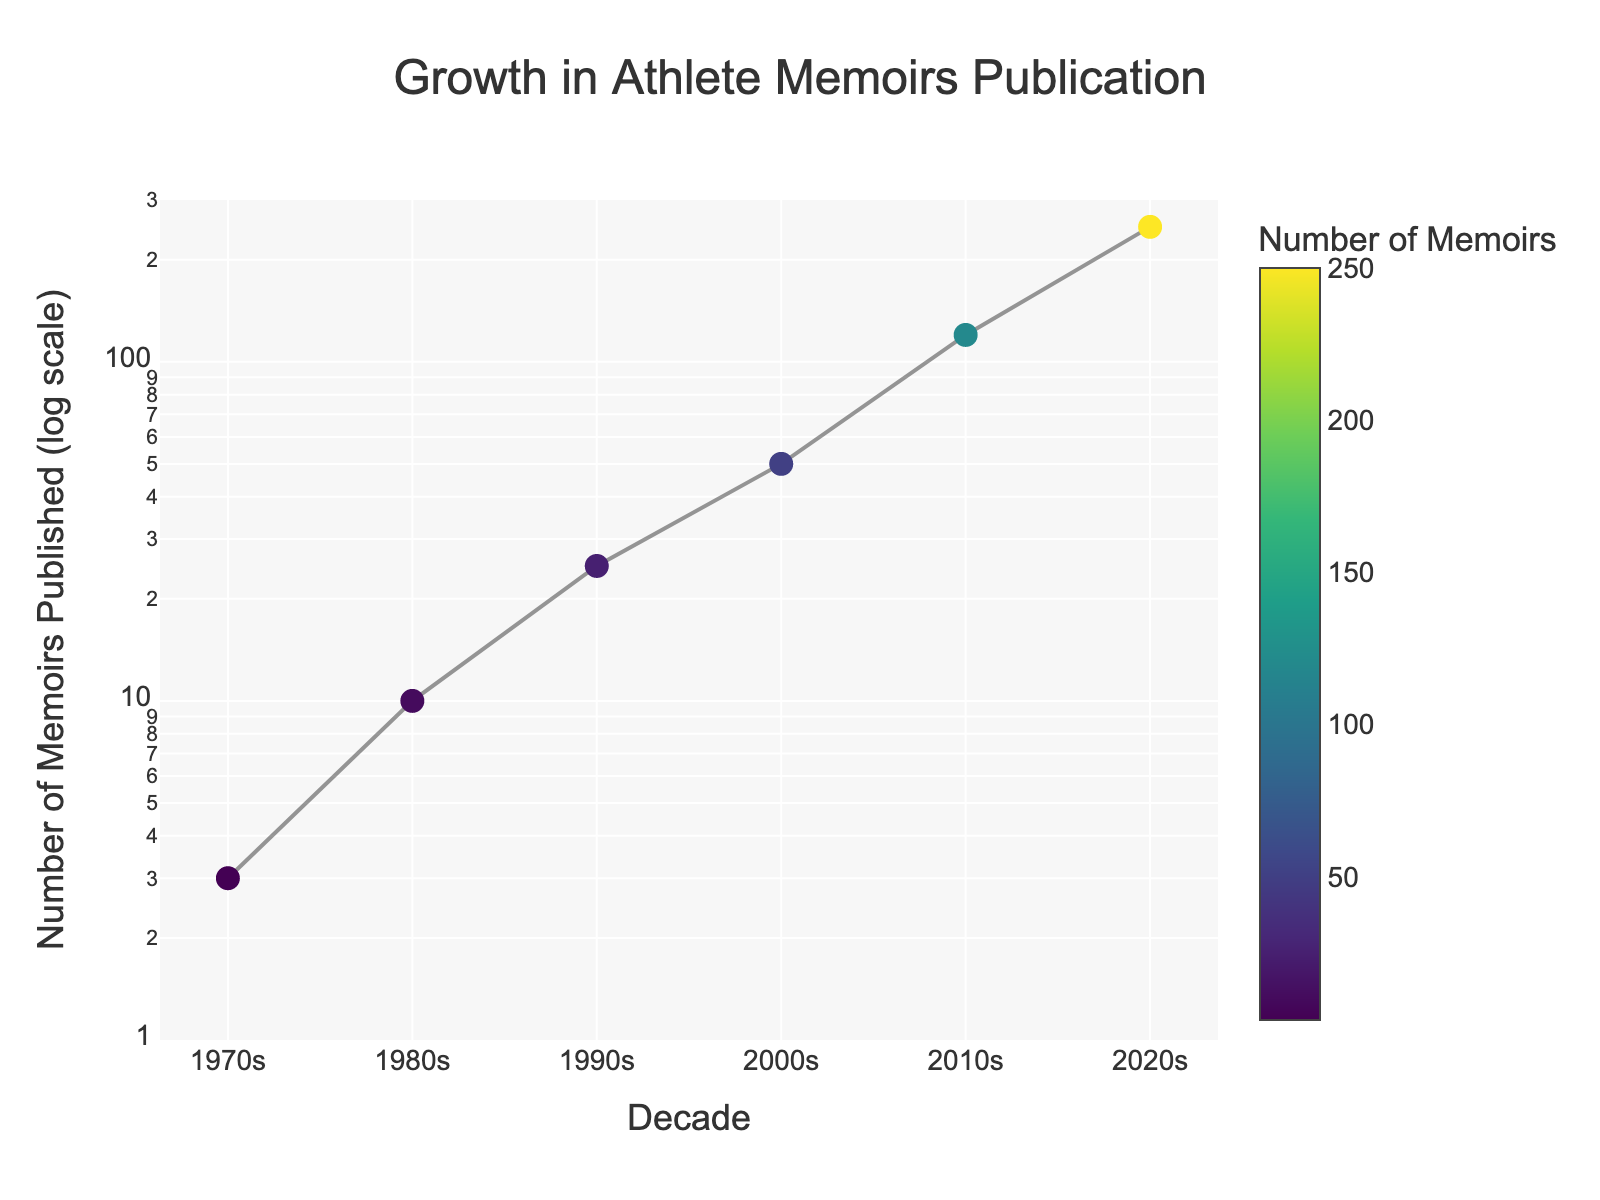What is the title of the figure? The title of the figure is displayed at the top and reads "Growth in Athlete Memoirs Publication."
Answer: Growth in Athlete Memoirs Publication Which decade shows the highest number of athlete memoirs published? By observing the y-axis and the annotations for each decade, it is clear that the 2020s show the highest number of 250 athlete memoirs published.
Answer: 2020s What is the number of athlete memoirs published in the 1980s? The annotation near the data point for the 1980s shows the number of athlete memoirs published, which is 10.
Answer: 10 How many more athlete memoirs were published in the 2000s compared to the 1990s? The number of memoirs published in the 2000s is 50, and in the 1990s, it is 25. The difference is 50 - 25 = 25 memoirs.
Answer: 25 By what factor did the number of published athlete memoirs increase from the 1990s to the 2010s? The number of memoirs published in the 1990s is 25. In the 2010s, it is 120. The factor of increase is 120 ÷ 25 = 4.8.
Answer: 4.8 What logarithmic value range is used for the y-axis? The y-axis is set to a log scale, and the logarithmic range provided in the code is from 0 to log10(300). Log10(300) approximately equals 2.477.
Answer: 0 to 2.477 Which decade shows a doubling of the number of athlete memoirs published compared to the previous decade? Comparing the annotated memoir counts, from the 1970s (3) to the 1980s (10), more than doubles. From the 1990s (25) to the 2000s (50), the number doubles. Hence, the number of memoirs doubled from the 1990s to the 2000s.
Answer: 2000s How does the plot indicate the number of memoirs for each decade? The number of memoirs for each decade is marked by data points connected by a line, and an annotation near each point showing the exact number of memoirs.
Answer: Marked points with annotations By approximately what percentage did the number of athlete memoirs published increase from the 2000s to the 2010s? The number of memoirs published increased from 50 in the 2000s to 120 in the 2010s. The percentage increase is calculated as ((120 - 50) / 50) × 100 = 140%.
Answer: 140% 